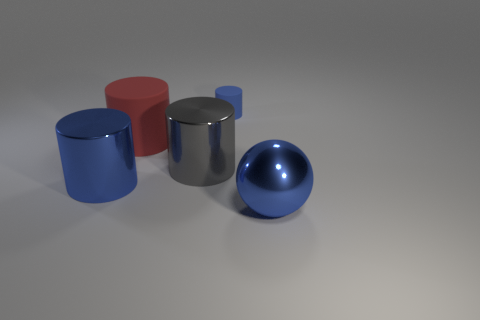Do the rubber cylinder in front of the blue matte cylinder and the small blue thing have the same size?
Your answer should be compact. No. There is a blue thing that is to the left of the shiny sphere and in front of the large red rubber thing; what shape is it?
Provide a succinct answer. Cylinder. Are there any big gray cylinders in front of the small blue cylinder?
Your answer should be compact. Yes. Is there any other thing that is the same shape as the tiny blue object?
Offer a very short reply. Yes. Is the red object the same shape as the tiny blue thing?
Offer a very short reply. Yes. Are there the same number of tiny objects left of the large red matte cylinder and small rubber cylinders left of the small rubber cylinder?
Your answer should be compact. Yes. What number of other things are there of the same material as the red thing
Provide a succinct answer. 1. How many small objects are green metallic balls or red cylinders?
Offer a very short reply. 0. Is the number of small matte objects left of the big blue metal cylinder the same as the number of metallic spheres?
Offer a terse response. No. Is there a big gray thing on the right side of the shiny cylinder behind the blue metal cylinder?
Your answer should be very brief. No. 